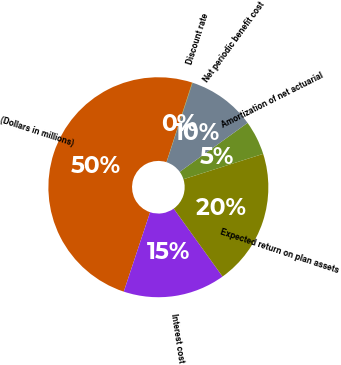<chart> <loc_0><loc_0><loc_500><loc_500><pie_chart><fcel>(Dollars in millions)<fcel>Interest cost<fcel>Expected return on plan assets<fcel>Amortization of net actuarial<fcel>Net periodic benefit cost<fcel>Discount rate<nl><fcel>49.88%<fcel>15.01%<fcel>19.99%<fcel>5.04%<fcel>10.02%<fcel>0.06%<nl></chart> 